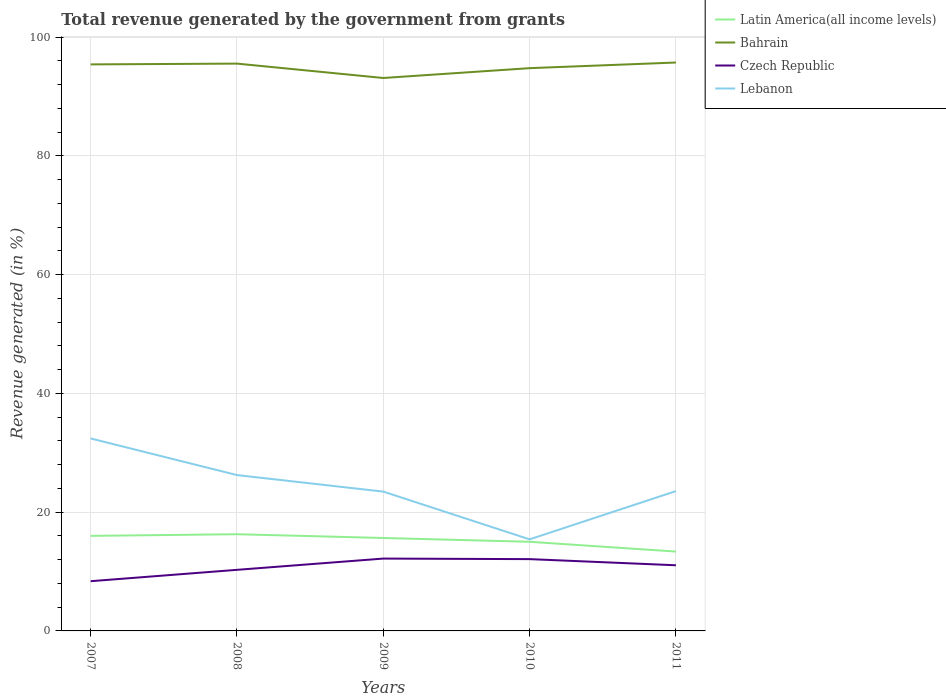Is the number of lines equal to the number of legend labels?
Your response must be concise. Yes. Across all years, what is the maximum total revenue generated in Bahrain?
Your answer should be compact. 93.12. What is the total total revenue generated in Czech Republic in the graph?
Your answer should be compact. 1.13. What is the difference between the highest and the second highest total revenue generated in Czech Republic?
Give a very brief answer. 3.81. What is the difference between the highest and the lowest total revenue generated in Lebanon?
Your response must be concise. 2. Is the total revenue generated in Czech Republic strictly greater than the total revenue generated in Latin America(all income levels) over the years?
Offer a terse response. Yes. How many lines are there?
Ensure brevity in your answer.  4. How many years are there in the graph?
Keep it short and to the point. 5. Are the values on the major ticks of Y-axis written in scientific E-notation?
Keep it short and to the point. No. Does the graph contain any zero values?
Give a very brief answer. No. Does the graph contain grids?
Ensure brevity in your answer.  Yes. What is the title of the graph?
Make the answer very short. Total revenue generated by the government from grants. Does "Paraguay" appear as one of the legend labels in the graph?
Provide a succinct answer. No. What is the label or title of the X-axis?
Ensure brevity in your answer.  Years. What is the label or title of the Y-axis?
Make the answer very short. Revenue generated (in %). What is the Revenue generated (in %) in Latin America(all income levels) in 2007?
Your answer should be very brief. 16.01. What is the Revenue generated (in %) of Bahrain in 2007?
Your answer should be very brief. 95.41. What is the Revenue generated (in %) in Czech Republic in 2007?
Provide a short and direct response. 8.37. What is the Revenue generated (in %) of Lebanon in 2007?
Provide a short and direct response. 32.41. What is the Revenue generated (in %) of Latin America(all income levels) in 2008?
Ensure brevity in your answer.  16.29. What is the Revenue generated (in %) of Bahrain in 2008?
Your answer should be compact. 95.54. What is the Revenue generated (in %) in Czech Republic in 2008?
Your answer should be compact. 10.29. What is the Revenue generated (in %) in Lebanon in 2008?
Give a very brief answer. 26.24. What is the Revenue generated (in %) in Latin America(all income levels) in 2009?
Make the answer very short. 15.65. What is the Revenue generated (in %) in Bahrain in 2009?
Your answer should be very brief. 93.12. What is the Revenue generated (in %) in Czech Republic in 2009?
Make the answer very short. 12.18. What is the Revenue generated (in %) in Lebanon in 2009?
Offer a terse response. 23.46. What is the Revenue generated (in %) of Latin America(all income levels) in 2010?
Your answer should be very brief. 15.01. What is the Revenue generated (in %) of Bahrain in 2010?
Your answer should be compact. 94.77. What is the Revenue generated (in %) in Czech Republic in 2010?
Provide a succinct answer. 12.09. What is the Revenue generated (in %) of Lebanon in 2010?
Provide a short and direct response. 15.42. What is the Revenue generated (in %) in Latin America(all income levels) in 2011?
Offer a very short reply. 13.36. What is the Revenue generated (in %) of Bahrain in 2011?
Offer a very short reply. 95.72. What is the Revenue generated (in %) of Czech Republic in 2011?
Provide a succinct answer. 11.06. What is the Revenue generated (in %) of Lebanon in 2011?
Give a very brief answer. 23.55. Across all years, what is the maximum Revenue generated (in %) in Latin America(all income levels)?
Provide a succinct answer. 16.29. Across all years, what is the maximum Revenue generated (in %) of Bahrain?
Provide a succinct answer. 95.72. Across all years, what is the maximum Revenue generated (in %) in Czech Republic?
Provide a short and direct response. 12.18. Across all years, what is the maximum Revenue generated (in %) in Lebanon?
Your answer should be very brief. 32.41. Across all years, what is the minimum Revenue generated (in %) of Latin America(all income levels)?
Give a very brief answer. 13.36. Across all years, what is the minimum Revenue generated (in %) of Bahrain?
Make the answer very short. 93.12. Across all years, what is the minimum Revenue generated (in %) of Czech Republic?
Offer a terse response. 8.37. Across all years, what is the minimum Revenue generated (in %) of Lebanon?
Ensure brevity in your answer.  15.42. What is the total Revenue generated (in %) in Latin America(all income levels) in the graph?
Provide a succinct answer. 76.32. What is the total Revenue generated (in %) of Bahrain in the graph?
Offer a terse response. 474.56. What is the total Revenue generated (in %) in Czech Republic in the graph?
Offer a terse response. 53.99. What is the total Revenue generated (in %) in Lebanon in the graph?
Keep it short and to the point. 121.09. What is the difference between the Revenue generated (in %) in Latin America(all income levels) in 2007 and that in 2008?
Offer a terse response. -0.28. What is the difference between the Revenue generated (in %) in Bahrain in 2007 and that in 2008?
Provide a short and direct response. -0.13. What is the difference between the Revenue generated (in %) of Czech Republic in 2007 and that in 2008?
Give a very brief answer. -1.91. What is the difference between the Revenue generated (in %) of Lebanon in 2007 and that in 2008?
Keep it short and to the point. 6.17. What is the difference between the Revenue generated (in %) of Latin America(all income levels) in 2007 and that in 2009?
Keep it short and to the point. 0.36. What is the difference between the Revenue generated (in %) in Bahrain in 2007 and that in 2009?
Offer a terse response. 2.29. What is the difference between the Revenue generated (in %) of Czech Republic in 2007 and that in 2009?
Offer a very short reply. -3.81. What is the difference between the Revenue generated (in %) in Lebanon in 2007 and that in 2009?
Offer a terse response. 8.95. What is the difference between the Revenue generated (in %) in Latin America(all income levels) in 2007 and that in 2010?
Ensure brevity in your answer.  1. What is the difference between the Revenue generated (in %) of Bahrain in 2007 and that in 2010?
Your response must be concise. 0.63. What is the difference between the Revenue generated (in %) of Czech Republic in 2007 and that in 2010?
Keep it short and to the point. -3.72. What is the difference between the Revenue generated (in %) in Lebanon in 2007 and that in 2010?
Give a very brief answer. 16.99. What is the difference between the Revenue generated (in %) in Latin America(all income levels) in 2007 and that in 2011?
Give a very brief answer. 2.64. What is the difference between the Revenue generated (in %) in Bahrain in 2007 and that in 2011?
Your response must be concise. -0.32. What is the difference between the Revenue generated (in %) of Czech Republic in 2007 and that in 2011?
Make the answer very short. -2.68. What is the difference between the Revenue generated (in %) of Lebanon in 2007 and that in 2011?
Give a very brief answer. 8.87. What is the difference between the Revenue generated (in %) of Latin America(all income levels) in 2008 and that in 2009?
Your response must be concise. 0.63. What is the difference between the Revenue generated (in %) of Bahrain in 2008 and that in 2009?
Offer a terse response. 2.42. What is the difference between the Revenue generated (in %) of Czech Republic in 2008 and that in 2009?
Give a very brief answer. -1.9. What is the difference between the Revenue generated (in %) of Lebanon in 2008 and that in 2009?
Your answer should be very brief. 2.78. What is the difference between the Revenue generated (in %) in Latin America(all income levels) in 2008 and that in 2010?
Your answer should be compact. 1.27. What is the difference between the Revenue generated (in %) in Bahrain in 2008 and that in 2010?
Your answer should be compact. 0.77. What is the difference between the Revenue generated (in %) in Czech Republic in 2008 and that in 2010?
Give a very brief answer. -1.8. What is the difference between the Revenue generated (in %) in Lebanon in 2008 and that in 2010?
Offer a terse response. 10.82. What is the difference between the Revenue generated (in %) of Latin America(all income levels) in 2008 and that in 2011?
Your answer should be compact. 2.92. What is the difference between the Revenue generated (in %) in Bahrain in 2008 and that in 2011?
Offer a terse response. -0.19. What is the difference between the Revenue generated (in %) in Czech Republic in 2008 and that in 2011?
Provide a succinct answer. -0.77. What is the difference between the Revenue generated (in %) in Lebanon in 2008 and that in 2011?
Give a very brief answer. 2.7. What is the difference between the Revenue generated (in %) of Latin America(all income levels) in 2009 and that in 2010?
Your answer should be compact. 0.64. What is the difference between the Revenue generated (in %) in Bahrain in 2009 and that in 2010?
Offer a very short reply. -1.66. What is the difference between the Revenue generated (in %) in Czech Republic in 2009 and that in 2010?
Make the answer very short. 0.09. What is the difference between the Revenue generated (in %) of Lebanon in 2009 and that in 2010?
Keep it short and to the point. 8.04. What is the difference between the Revenue generated (in %) of Latin America(all income levels) in 2009 and that in 2011?
Offer a terse response. 2.29. What is the difference between the Revenue generated (in %) of Bahrain in 2009 and that in 2011?
Your response must be concise. -2.61. What is the difference between the Revenue generated (in %) in Czech Republic in 2009 and that in 2011?
Offer a very short reply. 1.13. What is the difference between the Revenue generated (in %) in Lebanon in 2009 and that in 2011?
Provide a short and direct response. -0.09. What is the difference between the Revenue generated (in %) in Latin America(all income levels) in 2010 and that in 2011?
Offer a very short reply. 1.65. What is the difference between the Revenue generated (in %) in Bahrain in 2010 and that in 2011?
Make the answer very short. -0.95. What is the difference between the Revenue generated (in %) in Czech Republic in 2010 and that in 2011?
Your answer should be very brief. 1.03. What is the difference between the Revenue generated (in %) of Lebanon in 2010 and that in 2011?
Give a very brief answer. -8.13. What is the difference between the Revenue generated (in %) in Latin America(all income levels) in 2007 and the Revenue generated (in %) in Bahrain in 2008?
Provide a succinct answer. -79.53. What is the difference between the Revenue generated (in %) in Latin America(all income levels) in 2007 and the Revenue generated (in %) in Czech Republic in 2008?
Keep it short and to the point. 5.72. What is the difference between the Revenue generated (in %) of Latin America(all income levels) in 2007 and the Revenue generated (in %) of Lebanon in 2008?
Ensure brevity in your answer.  -10.24. What is the difference between the Revenue generated (in %) in Bahrain in 2007 and the Revenue generated (in %) in Czech Republic in 2008?
Your answer should be very brief. 85.12. What is the difference between the Revenue generated (in %) of Bahrain in 2007 and the Revenue generated (in %) of Lebanon in 2008?
Your answer should be compact. 69.16. What is the difference between the Revenue generated (in %) of Czech Republic in 2007 and the Revenue generated (in %) of Lebanon in 2008?
Ensure brevity in your answer.  -17.87. What is the difference between the Revenue generated (in %) in Latin America(all income levels) in 2007 and the Revenue generated (in %) in Bahrain in 2009?
Provide a succinct answer. -77.11. What is the difference between the Revenue generated (in %) of Latin America(all income levels) in 2007 and the Revenue generated (in %) of Czech Republic in 2009?
Ensure brevity in your answer.  3.82. What is the difference between the Revenue generated (in %) in Latin America(all income levels) in 2007 and the Revenue generated (in %) in Lebanon in 2009?
Your response must be concise. -7.45. What is the difference between the Revenue generated (in %) in Bahrain in 2007 and the Revenue generated (in %) in Czech Republic in 2009?
Your answer should be very brief. 83.22. What is the difference between the Revenue generated (in %) in Bahrain in 2007 and the Revenue generated (in %) in Lebanon in 2009?
Your answer should be very brief. 71.95. What is the difference between the Revenue generated (in %) of Czech Republic in 2007 and the Revenue generated (in %) of Lebanon in 2009?
Your response must be concise. -15.09. What is the difference between the Revenue generated (in %) of Latin America(all income levels) in 2007 and the Revenue generated (in %) of Bahrain in 2010?
Provide a short and direct response. -78.77. What is the difference between the Revenue generated (in %) in Latin America(all income levels) in 2007 and the Revenue generated (in %) in Czech Republic in 2010?
Provide a succinct answer. 3.92. What is the difference between the Revenue generated (in %) of Latin America(all income levels) in 2007 and the Revenue generated (in %) of Lebanon in 2010?
Your answer should be compact. 0.59. What is the difference between the Revenue generated (in %) of Bahrain in 2007 and the Revenue generated (in %) of Czech Republic in 2010?
Make the answer very short. 83.32. What is the difference between the Revenue generated (in %) in Bahrain in 2007 and the Revenue generated (in %) in Lebanon in 2010?
Ensure brevity in your answer.  79.99. What is the difference between the Revenue generated (in %) of Czech Republic in 2007 and the Revenue generated (in %) of Lebanon in 2010?
Provide a succinct answer. -7.05. What is the difference between the Revenue generated (in %) in Latin America(all income levels) in 2007 and the Revenue generated (in %) in Bahrain in 2011?
Your answer should be compact. -79.72. What is the difference between the Revenue generated (in %) of Latin America(all income levels) in 2007 and the Revenue generated (in %) of Czech Republic in 2011?
Offer a terse response. 4.95. What is the difference between the Revenue generated (in %) of Latin America(all income levels) in 2007 and the Revenue generated (in %) of Lebanon in 2011?
Offer a terse response. -7.54. What is the difference between the Revenue generated (in %) in Bahrain in 2007 and the Revenue generated (in %) in Czech Republic in 2011?
Offer a very short reply. 84.35. What is the difference between the Revenue generated (in %) in Bahrain in 2007 and the Revenue generated (in %) in Lebanon in 2011?
Give a very brief answer. 71.86. What is the difference between the Revenue generated (in %) of Czech Republic in 2007 and the Revenue generated (in %) of Lebanon in 2011?
Keep it short and to the point. -15.17. What is the difference between the Revenue generated (in %) of Latin America(all income levels) in 2008 and the Revenue generated (in %) of Bahrain in 2009?
Keep it short and to the point. -76.83. What is the difference between the Revenue generated (in %) in Latin America(all income levels) in 2008 and the Revenue generated (in %) in Czech Republic in 2009?
Make the answer very short. 4.1. What is the difference between the Revenue generated (in %) in Latin America(all income levels) in 2008 and the Revenue generated (in %) in Lebanon in 2009?
Your response must be concise. -7.18. What is the difference between the Revenue generated (in %) in Bahrain in 2008 and the Revenue generated (in %) in Czech Republic in 2009?
Your answer should be compact. 83.35. What is the difference between the Revenue generated (in %) of Bahrain in 2008 and the Revenue generated (in %) of Lebanon in 2009?
Provide a succinct answer. 72.08. What is the difference between the Revenue generated (in %) in Czech Republic in 2008 and the Revenue generated (in %) in Lebanon in 2009?
Provide a succinct answer. -13.17. What is the difference between the Revenue generated (in %) of Latin America(all income levels) in 2008 and the Revenue generated (in %) of Bahrain in 2010?
Ensure brevity in your answer.  -78.49. What is the difference between the Revenue generated (in %) of Latin America(all income levels) in 2008 and the Revenue generated (in %) of Czech Republic in 2010?
Your answer should be compact. 4.19. What is the difference between the Revenue generated (in %) in Latin America(all income levels) in 2008 and the Revenue generated (in %) in Lebanon in 2010?
Make the answer very short. 0.86. What is the difference between the Revenue generated (in %) of Bahrain in 2008 and the Revenue generated (in %) of Czech Republic in 2010?
Ensure brevity in your answer.  83.45. What is the difference between the Revenue generated (in %) of Bahrain in 2008 and the Revenue generated (in %) of Lebanon in 2010?
Your answer should be compact. 80.12. What is the difference between the Revenue generated (in %) of Czech Republic in 2008 and the Revenue generated (in %) of Lebanon in 2010?
Provide a succinct answer. -5.13. What is the difference between the Revenue generated (in %) in Latin America(all income levels) in 2008 and the Revenue generated (in %) in Bahrain in 2011?
Keep it short and to the point. -79.44. What is the difference between the Revenue generated (in %) in Latin America(all income levels) in 2008 and the Revenue generated (in %) in Czech Republic in 2011?
Provide a short and direct response. 5.23. What is the difference between the Revenue generated (in %) in Latin America(all income levels) in 2008 and the Revenue generated (in %) in Lebanon in 2011?
Keep it short and to the point. -7.26. What is the difference between the Revenue generated (in %) of Bahrain in 2008 and the Revenue generated (in %) of Czech Republic in 2011?
Your answer should be compact. 84.48. What is the difference between the Revenue generated (in %) of Bahrain in 2008 and the Revenue generated (in %) of Lebanon in 2011?
Your answer should be very brief. 71.99. What is the difference between the Revenue generated (in %) of Czech Republic in 2008 and the Revenue generated (in %) of Lebanon in 2011?
Your response must be concise. -13.26. What is the difference between the Revenue generated (in %) of Latin America(all income levels) in 2009 and the Revenue generated (in %) of Bahrain in 2010?
Make the answer very short. -79.12. What is the difference between the Revenue generated (in %) of Latin America(all income levels) in 2009 and the Revenue generated (in %) of Czech Republic in 2010?
Offer a very short reply. 3.56. What is the difference between the Revenue generated (in %) of Latin America(all income levels) in 2009 and the Revenue generated (in %) of Lebanon in 2010?
Ensure brevity in your answer.  0.23. What is the difference between the Revenue generated (in %) of Bahrain in 2009 and the Revenue generated (in %) of Czech Republic in 2010?
Keep it short and to the point. 81.03. What is the difference between the Revenue generated (in %) in Bahrain in 2009 and the Revenue generated (in %) in Lebanon in 2010?
Your answer should be very brief. 77.7. What is the difference between the Revenue generated (in %) in Czech Republic in 2009 and the Revenue generated (in %) in Lebanon in 2010?
Provide a succinct answer. -3.24. What is the difference between the Revenue generated (in %) in Latin America(all income levels) in 2009 and the Revenue generated (in %) in Bahrain in 2011?
Your response must be concise. -80.07. What is the difference between the Revenue generated (in %) in Latin America(all income levels) in 2009 and the Revenue generated (in %) in Czech Republic in 2011?
Keep it short and to the point. 4.59. What is the difference between the Revenue generated (in %) of Latin America(all income levels) in 2009 and the Revenue generated (in %) of Lebanon in 2011?
Offer a terse response. -7.9. What is the difference between the Revenue generated (in %) in Bahrain in 2009 and the Revenue generated (in %) in Czech Republic in 2011?
Your response must be concise. 82.06. What is the difference between the Revenue generated (in %) in Bahrain in 2009 and the Revenue generated (in %) in Lebanon in 2011?
Ensure brevity in your answer.  69.57. What is the difference between the Revenue generated (in %) in Czech Republic in 2009 and the Revenue generated (in %) in Lebanon in 2011?
Give a very brief answer. -11.36. What is the difference between the Revenue generated (in %) in Latin America(all income levels) in 2010 and the Revenue generated (in %) in Bahrain in 2011?
Provide a succinct answer. -80.71. What is the difference between the Revenue generated (in %) of Latin America(all income levels) in 2010 and the Revenue generated (in %) of Czech Republic in 2011?
Ensure brevity in your answer.  3.95. What is the difference between the Revenue generated (in %) in Latin America(all income levels) in 2010 and the Revenue generated (in %) in Lebanon in 2011?
Provide a succinct answer. -8.54. What is the difference between the Revenue generated (in %) in Bahrain in 2010 and the Revenue generated (in %) in Czech Republic in 2011?
Offer a terse response. 83.72. What is the difference between the Revenue generated (in %) of Bahrain in 2010 and the Revenue generated (in %) of Lebanon in 2011?
Offer a terse response. 71.23. What is the difference between the Revenue generated (in %) in Czech Republic in 2010 and the Revenue generated (in %) in Lebanon in 2011?
Make the answer very short. -11.46. What is the average Revenue generated (in %) in Latin America(all income levels) per year?
Your answer should be very brief. 15.26. What is the average Revenue generated (in %) in Bahrain per year?
Provide a succinct answer. 94.91. What is the average Revenue generated (in %) of Czech Republic per year?
Your response must be concise. 10.8. What is the average Revenue generated (in %) in Lebanon per year?
Ensure brevity in your answer.  24.22. In the year 2007, what is the difference between the Revenue generated (in %) of Latin America(all income levels) and Revenue generated (in %) of Bahrain?
Offer a terse response. -79.4. In the year 2007, what is the difference between the Revenue generated (in %) in Latin America(all income levels) and Revenue generated (in %) in Czech Republic?
Your answer should be compact. 7.63. In the year 2007, what is the difference between the Revenue generated (in %) in Latin America(all income levels) and Revenue generated (in %) in Lebanon?
Keep it short and to the point. -16.4. In the year 2007, what is the difference between the Revenue generated (in %) in Bahrain and Revenue generated (in %) in Czech Republic?
Ensure brevity in your answer.  87.03. In the year 2007, what is the difference between the Revenue generated (in %) in Bahrain and Revenue generated (in %) in Lebanon?
Ensure brevity in your answer.  62.99. In the year 2007, what is the difference between the Revenue generated (in %) in Czech Republic and Revenue generated (in %) in Lebanon?
Give a very brief answer. -24.04. In the year 2008, what is the difference between the Revenue generated (in %) of Latin America(all income levels) and Revenue generated (in %) of Bahrain?
Make the answer very short. -79.25. In the year 2008, what is the difference between the Revenue generated (in %) in Latin America(all income levels) and Revenue generated (in %) in Czech Republic?
Provide a succinct answer. 6. In the year 2008, what is the difference between the Revenue generated (in %) in Latin America(all income levels) and Revenue generated (in %) in Lebanon?
Your answer should be very brief. -9.96. In the year 2008, what is the difference between the Revenue generated (in %) of Bahrain and Revenue generated (in %) of Czech Republic?
Provide a short and direct response. 85.25. In the year 2008, what is the difference between the Revenue generated (in %) of Bahrain and Revenue generated (in %) of Lebanon?
Provide a succinct answer. 69.29. In the year 2008, what is the difference between the Revenue generated (in %) in Czech Republic and Revenue generated (in %) in Lebanon?
Your response must be concise. -15.96. In the year 2009, what is the difference between the Revenue generated (in %) of Latin America(all income levels) and Revenue generated (in %) of Bahrain?
Give a very brief answer. -77.47. In the year 2009, what is the difference between the Revenue generated (in %) of Latin America(all income levels) and Revenue generated (in %) of Czech Republic?
Your answer should be very brief. 3.47. In the year 2009, what is the difference between the Revenue generated (in %) of Latin America(all income levels) and Revenue generated (in %) of Lebanon?
Your response must be concise. -7.81. In the year 2009, what is the difference between the Revenue generated (in %) in Bahrain and Revenue generated (in %) in Czech Republic?
Give a very brief answer. 80.93. In the year 2009, what is the difference between the Revenue generated (in %) of Bahrain and Revenue generated (in %) of Lebanon?
Make the answer very short. 69.66. In the year 2009, what is the difference between the Revenue generated (in %) of Czech Republic and Revenue generated (in %) of Lebanon?
Provide a succinct answer. -11.28. In the year 2010, what is the difference between the Revenue generated (in %) of Latin America(all income levels) and Revenue generated (in %) of Bahrain?
Your answer should be compact. -79.76. In the year 2010, what is the difference between the Revenue generated (in %) in Latin America(all income levels) and Revenue generated (in %) in Czech Republic?
Ensure brevity in your answer.  2.92. In the year 2010, what is the difference between the Revenue generated (in %) in Latin America(all income levels) and Revenue generated (in %) in Lebanon?
Keep it short and to the point. -0.41. In the year 2010, what is the difference between the Revenue generated (in %) of Bahrain and Revenue generated (in %) of Czech Republic?
Offer a very short reply. 82.68. In the year 2010, what is the difference between the Revenue generated (in %) of Bahrain and Revenue generated (in %) of Lebanon?
Make the answer very short. 79.35. In the year 2010, what is the difference between the Revenue generated (in %) in Czech Republic and Revenue generated (in %) in Lebanon?
Your answer should be compact. -3.33. In the year 2011, what is the difference between the Revenue generated (in %) in Latin America(all income levels) and Revenue generated (in %) in Bahrain?
Offer a terse response. -82.36. In the year 2011, what is the difference between the Revenue generated (in %) of Latin America(all income levels) and Revenue generated (in %) of Czech Republic?
Provide a short and direct response. 2.31. In the year 2011, what is the difference between the Revenue generated (in %) in Latin America(all income levels) and Revenue generated (in %) in Lebanon?
Make the answer very short. -10.18. In the year 2011, what is the difference between the Revenue generated (in %) in Bahrain and Revenue generated (in %) in Czech Republic?
Ensure brevity in your answer.  84.67. In the year 2011, what is the difference between the Revenue generated (in %) in Bahrain and Revenue generated (in %) in Lebanon?
Make the answer very short. 72.18. In the year 2011, what is the difference between the Revenue generated (in %) of Czech Republic and Revenue generated (in %) of Lebanon?
Make the answer very short. -12.49. What is the ratio of the Revenue generated (in %) in Czech Republic in 2007 to that in 2008?
Ensure brevity in your answer.  0.81. What is the ratio of the Revenue generated (in %) in Lebanon in 2007 to that in 2008?
Give a very brief answer. 1.24. What is the ratio of the Revenue generated (in %) of Latin America(all income levels) in 2007 to that in 2009?
Offer a terse response. 1.02. What is the ratio of the Revenue generated (in %) in Bahrain in 2007 to that in 2009?
Your answer should be very brief. 1.02. What is the ratio of the Revenue generated (in %) in Czech Republic in 2007 to that in 2009?
Your response must be concise. 0.69. What is the ratio of the Revenue generated (in %) of Lebanon in 2007 to that in 2009?
Offer a terse response. 1.38. What is the ratio of the Revenue generated (in %) of Latin America(all income levels) in 2007 to that in 2010?
Offer a terse response. 1.07. What is the ratio of the Revenue generated (in %) in Bahrain in 2007 to that in 2010?
Your answer should be very brief. 1.01. What is the ratio of the Revenue generated (in %) of Czech Republic in 2007 to that in 2010?
Make the answer very short. 0.69. What is the ratio of the Revenue generated (in %) in Lebanon in 2007 to that in 2010?
Offer a very short reply. 2.1. What is the ratio of the Revenue generated (in %) of Latin America(all income levels) in 2007 to that in 2011?
Provide a short and direct response. 1.2. What is the ratio of the Revenue generated (in %) in Czech Republic in 2007 to that in 2011?
Provide a succinct answer. 0.76. What is the ratio of the Revenue generated (in %) in Lebanon in 2007 to that in 2011?
Provide a short and direct response. 1.38. What is the ratio of the Revenue generated (in %) of Latin America(all income levels) in 2008 to that in 2009?
Provide a short and direct response. 1.04. What is the ratio of the Revenue generated (in %) in Czech Republic in 2008 to that in 2009?
Your answer should be compact. 0.84. What is the ratio of the Revenue generated (in %) in Lebanon in 2008 to that in 2009?
Your response must be concise. 1.12. What is the ratio of the Revenue generated (in %) of Latin America(all income levels) in 2008 to that in 2010?
Provide a succinct answer. 1.08. What is the ratio of the Revenue generated (in %) in Bahrain in 2008 to that in 2010?
Give a very brief answer. 1.01. What is the ratio of the Revenue generated (in %) in Czech Republic in 2008 to that in 2010?
Your answer should be compact. 0.85. What is the ratio of the Revenue generated (in %) of Lebanon in 2008 to that in 2010?
Keep it short and to the point. 1.7. What is the ratio of the Revenue generated (in %) of Latin America(all income levels) in 2008 to that in 2011?
Make the answer very short. 1.22. What is the ratio of the Revenue generated (in %) in Bahrain in 2008 to that in 2011?
Ensure brevity in your answer.  1. What is the ratio of the Revenue generated (in %) of Czech Republic in 2008 to that in 2011?
Your answer should be compact. 0.93. What is the ratio of the Revenue generated (in %) of Lebanon in 2008 to that in 2011?
Ensure brevity in your answer.  1.11. What is the ratio of the Revenue generated (in %) of Latin America(all income levels) in 2009 to that in 2010?
Offer a very short reply. 1.04. What is the ratio of the Revenue generated (in %) of Bahrain in 2009 to that in 2010?
Provide a succinct answer. 0.98. What is the ratio of the Revenue generated (in %) in Czech Republic in 2009 to that in 2010?
Your answer should be compact. 1.01. What is the ratio of the Revenue generated (in %) of Lebanon in 2009 to that in 2010?
Ensure brevity in your answer.  1.52. What is the ratio of the Revenue generated (in %) in Latin America(all income levels) in 2009 to that in 2011?
Give a very brief answer. 1.17. What is the ratio of the Revenue generated (in %) of Bahrain in 2009 to that in 2011?
Offer a terse response. 0.97. What is the ratio of the Revenue generated (in %) of Czech Republic in 2009 to that in 2011?
Give a very brief answer. 1.1. What is the ratio of the Revenue generated (in %) in Lebanon in 2009 to that in 2011?
Keep it short and to the point. 1. What is the ratio of the Revenue generated (in %) in Latin America(all income levels) in 2010 to that in 2011?
Keep it short and to the point. 1.12. What is the ratio of the Revenue generated (in %) in Bahrain in 2010 to that in 2011?
Provide a short and direct response. 0.99. What is the ratio of the Revenue generated (in %) of Czech Republic in 2010 to that in 2011?
Keep it short and to the point. 1.09. What is the ratio of the Revenue generated (in %) of Lebanon in 2010 to that in 2011?
Provide a short and direct response. 0.65. What is the difference between the highest and the second highest Revenue generated (in %) in Latin America(all income levels)?
Provide a succinct answer. 0.28. What is the difference between the highest and the second highest Revenue generated (in %) in Bahrain?
Give a very brief answer. 0.19. What is the difference between the highest and the second highest Revenue generated (in %) in Czech Republic?
Provide a succinct answer. 0.09. What is the difference between the highest and the second highest Revenue generated (in %) of Lebanon?
Ensure brevity in your answer.  6.17. What is the difference between the highest and the lowest Revenue generated (in %) of Latin America(all income levels)?
Make the answer very short. 2.92. What is the difference between the highest and the lowest Revenue generated (in %) in Bahrain?
Your response must be concise. 2.61. What is the difference between the highest and the lowest Revenue generated (in %) of Czech Republic?
Provide a short and direct response. 3.81. What is the difference between the highest and the lowest Revenue generated (in %) of Lebanon?
Your response must be concise. 16.99. 